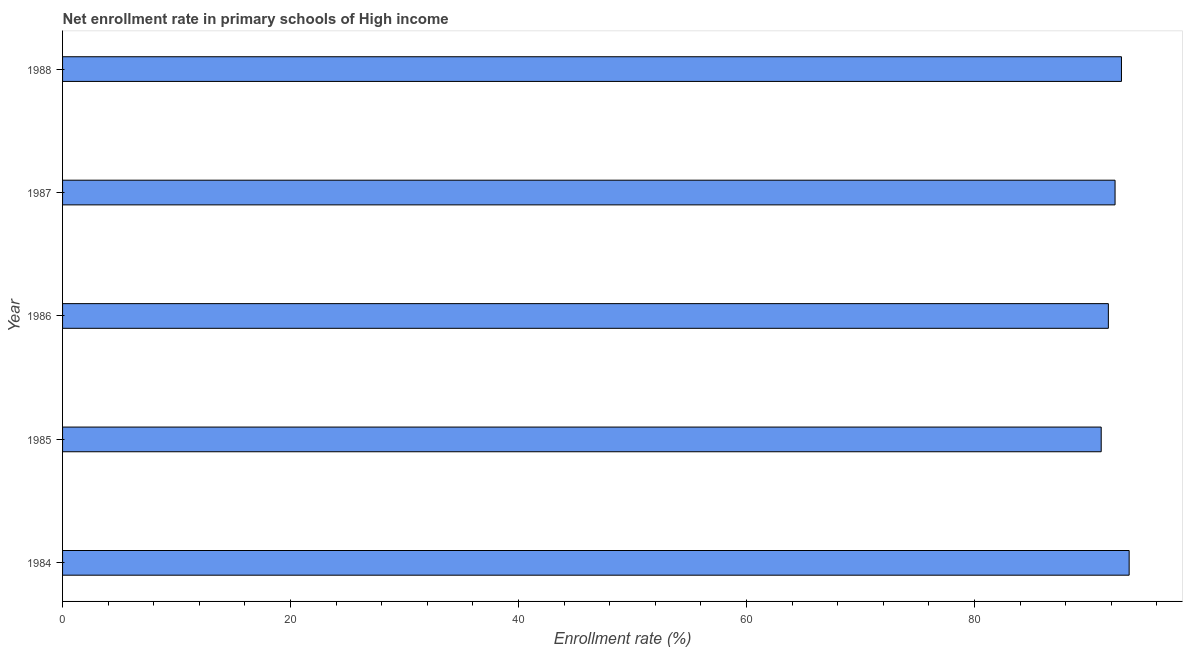Does the graph contain grids?
Provide a short and direct response. No. What is the title of the graph?
Provide a succinct answer. Net enrollment rate in primary schools of High income. What is the label or title of the X-axis?
Keep it short and to the point. Enrollment rate (%). What is the net enrollment rate in primary schools in 1985?
Offer a very short reply. 91.12. Across all years, what is the maximum net enrollment rate in primary schools?
Keep it short and to the point. 93.57. Across all years, what is the minimum net enrollment rate in primary schools?
Give a very brief answer. 91.12. In which year was the net enrollment rate in primary schools maximum?
Provide a succinct answer. 1984. In which year was the net enrollment rate in primary schools minimum?
Keep it short and to the point. 1985. What is the sum of the net enrollment rate in primary schools?
Ensure brevity in your answer.  461.69. What is the difference between the net enrollment rate in primary schools in 1985 and 1988?
Ensure brevity in your answer.  -1.78. What is the average net enrollment rate in primary schools per year?
Provide a succinct answer. 92.34. What is the median net enrollment rate in primary schools?
Keep it short and to the point. 92.34. In how many years, is the net enrollment rate in primary schools greater than 48 %?
Keep it short and to the point. 5. What is the ratio of the net enrollment rate in primary schools in 1984 to that in 1985?
Your answer should be compact. 1.03. Is the net enrollment rate in primary schools in 1985 less than that in 1987?
Provide a short and direct response. Yes. What is the difference between the highest and the second highest net enrollment rate in primary schools?
Your response must be concise. 0.67. Is the sum of the net enrollment rate in primary schools in 1984 and 1985 greater than the maximum net enrollment rate in primary schools across all years?
Your response must be concise. Yes. What is the difference between the highest and the lowest net enrollment rate in primary schools?
Provide a short and direct response. 2.45. In how many years, is the net enrollment rate in primary schools greater than the average net enrollment rate in primary schools taken over all years?
Offer a terse response. 3. How many bars are there?
Ensure brevity in your answer.  5. How many years are there in the graph?
Provide a short and direct response. 5. Are the values on the major ticks of X-axis written in scientific E-notation?
Provide a short and direct response. No. What is the Enrollment rate (%) in 1984?
Provide a short and direct response. 93.57. What is the Enrollment rate (%) in 1985?
Provide a short and direct response. 91.12. What is the Enrollment rate (%) of 1986?
Your response must be concise. 91.75. What is the Enrollment rate (%) of 1987?
Offer a terse response. 92.34. What is the Enrollment rate (%) of 1988?
Provide a succinct answer. 92.9. What is the difference between the Enrollment rate (%) in 1984 and 1985?
Offer a terse response. 2.45. What is the difference between the Enrollment rate (%) in 1984 and 1986?
Ensure brevity in your answer.  1.83. What is the difference between the Enrollment rate (%) in 1984 and 1987?
Give a very brief answer. 1.24. What is the difference between the Enrollment rate (%) in 1984 and 1988?
Provide a succinct answer. 0.67. What is the difference between the Enrollment rate (%) in 1985 and 1986?
Ensure brevity in your answer.  -0.63. What is the difference between the Enrollment rate (%) in 1985 and 1987?
Your response must be concise. -1.22. What is the difference between the Enrollment rate (%) in 1985 and 1988?
Offer a very short reply. -1.78. What is the difference between the Enrollment rate (%) in 1986 and 1987?
Give a very brief answer. -0.59. What is the difference between the Enrollment rate (%) in 1986 and 1988?
Give a very brief answer. -1.15. What is the difference between the Enrollment rate (%) in 1987 and 1988?
Make the answer very short. -0.56. What is the ratio of the Enrollment rate (%) in 1984 to that in 1986?
Offer a very short reply. 1.02. What is the ratio of the Enrollment rate (%) in 1984 to that in 1988?
Provide a succinct answer. 1.01. What is the ratio of the Enrollment rate (%) in 1985 to that in 1987?
Provide a short and direct response. 0.99. What is the ratio of the Enrollment rate (%) in 1986 to that in 1987?
Provide a short and direct response. 0.99. 